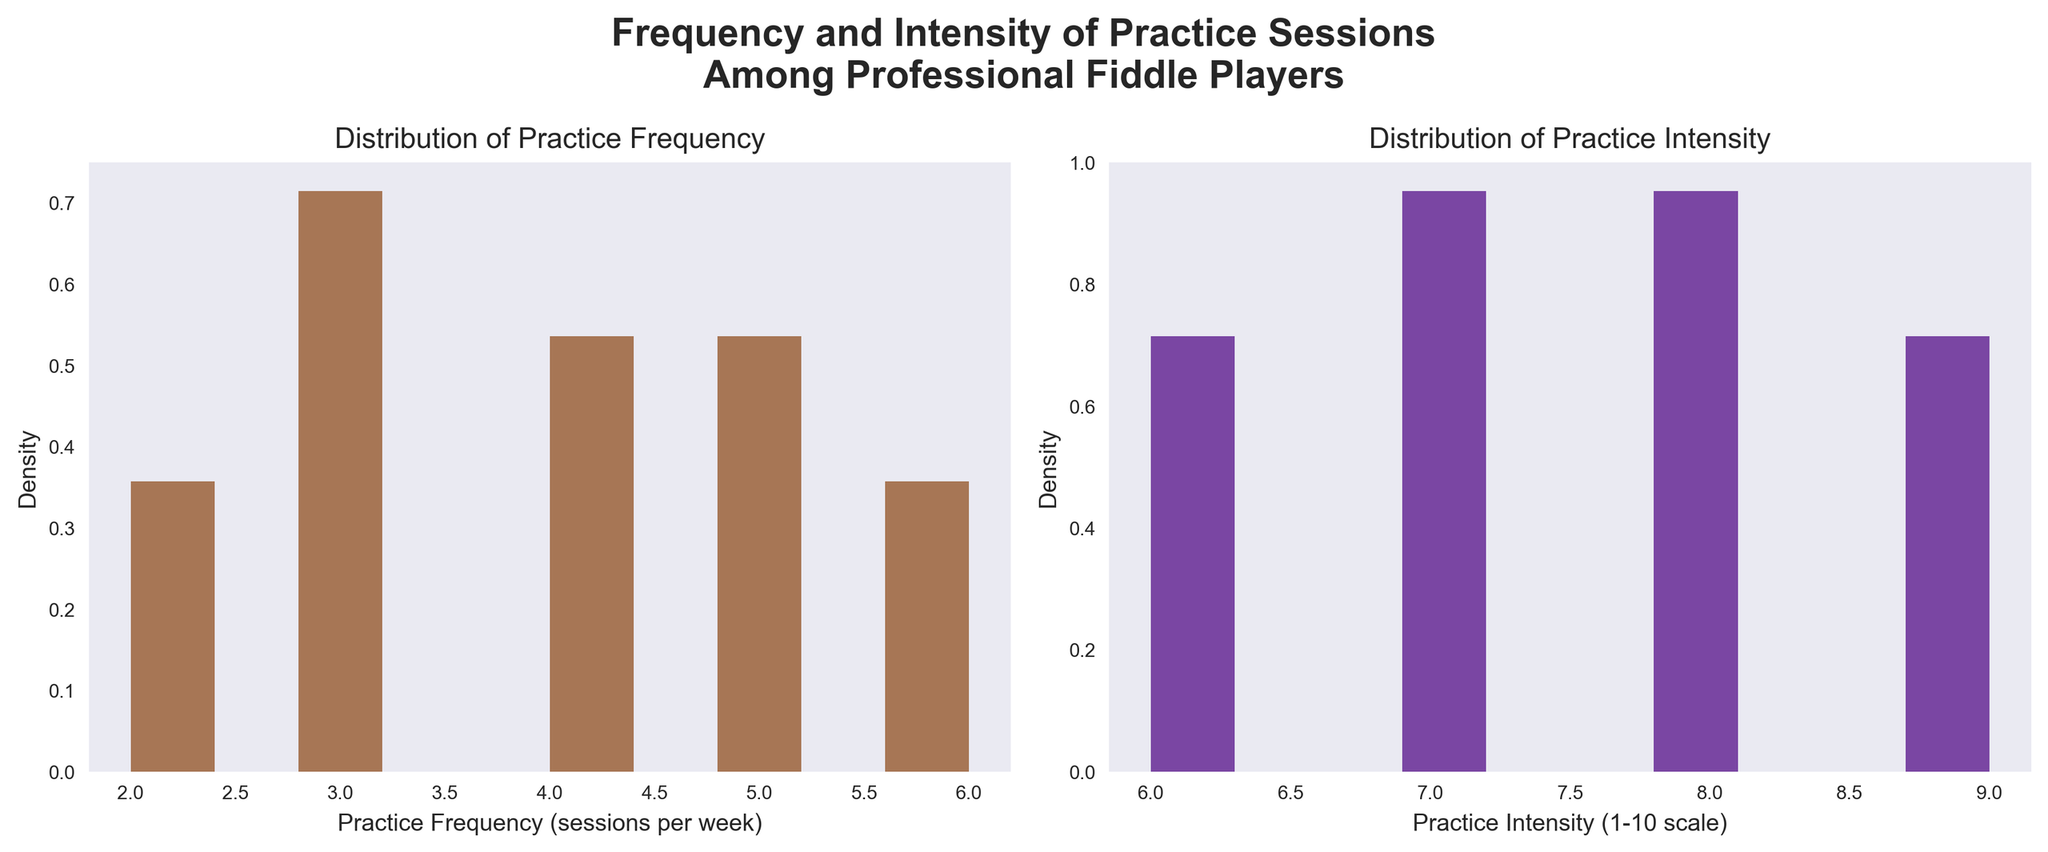what is the title of the plot? The title is written at the top of the figure and summarizes the content of the plot. The main title is 'Frequency and Intensity of Practice Sessions Among Professional Fiddle Players'.
Answer: Frequency and Intensity of Practice Sessions Among Professional Fiddle Players What are the x-axis labels of the two subplots? The x-axis labels are found at the bottom of each subplot, describing what is being measured. The x-axis label for the left subplot is 'Practice Frequency (sessions per week)', and for the right subplot, it is 'Practice Intensity (1-10 scale)'.
Answer: Practice Frequency (sessions per week) and Practice Intensity (1-10 scale) What color is used for the density plot of Practice Frequency? The color used for the density plot can be observed in the histogram bars on the left subplot. The density plot for Practice Frequency is in brown color.
Answer: Brown Which practice intensity appears to be most common among the players? To determine the most common or frequent practice intensity, one needs to look at the peak of the density plot on the right subplot. The intensity with the highest bar, indicating the most common intensity, is around '7'.
Answer: 7 How many bins are used for the density plots? Usually, the bins are small sections of the x-axis used for data aggregation in histograms. In both subplots, you can count the number of rectangular sections. Each density plot has 10 bins.
Answer: 10 What is the most common practice frequency among the players? This can be identified by looking at the highest bar in the density plot on the left subplot. The peak of the histogram indicates that the most common practice frequency is '3'.
Answer: 3 What is the range of practice frequencies? The range can be determined by looking at the minimum and maximum values on the x-axis of the left subplot. The practice frequencies range from '2' to '6'.
Answer: 2 to 6 Which practice-related measure shows a higher variation among the players? Higher variation can be judged by the spread of the histogram bars in each subplot. The distribution of Practice Intensity (right subplot) ranges wider, indicating a higher variation compared to Practice Frequency (left subplot).
Answer: Practice Intensity Which subplot shows a relatively uniform distribution? A uniform distribution would show histogram bars of similar height across the range. The subplot for Practice Intensity shows a more uniform distribution with bars not deviating too much compared to Practice Frequency.
Answer: Practice Intensity Is there any practice frequency that is not present among the players? By observing the histogram for Practice Frequency, we can identify if any x-axis values have no corresponding bars. The frequency '3' is indeed present, but '1' and '7' have no bars, indicating they are not present.
Answer: 1 and 7 